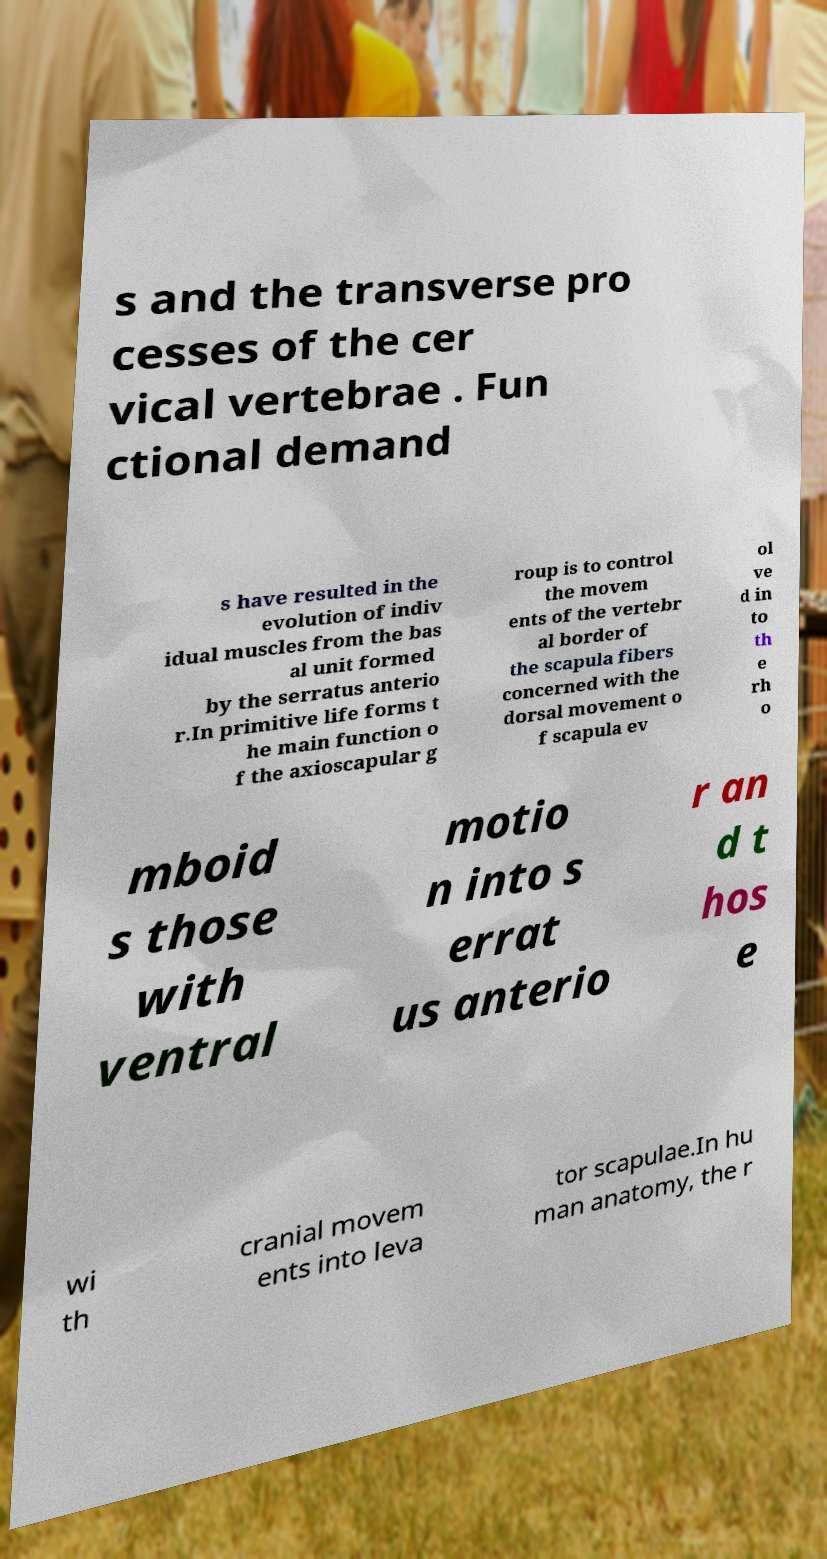Please read and relay the text visible in this image. What does it say? s and the transverse pro cesses of the cer vical vertebrae . Fun ctional demand s have resulted in the evolution of indiv idual muscles from the bas al unit formed by the serratus anterio r.In primitive life forms t he main function o f the axioscapular g roup is to control the movem ents of the vertebr al border of the scapula fibers concerned with the dorsal movement o f scapula ev ol ve d in to th e rh o mboid s those with ventral motio n into s errat us anterio r an d t hos e wi th cranial movem ents into leva tor scapulae.In hu man anatomy, the r 